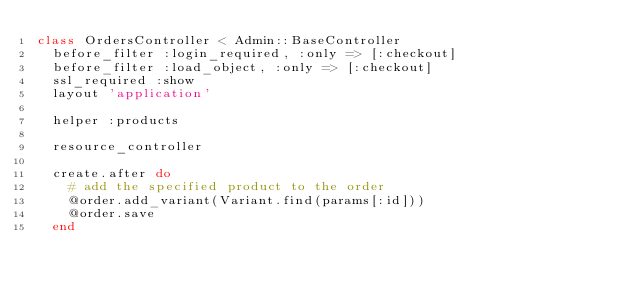<code> <loc_0><loc_0><loc_500><loc_500><_Ruby_>class OrdersController < Admin::BaseController
  before_filter :login_required, :only => [:checkout]
  before_filter :load_object, :only => [:checkout]
  ssl_required :show
  layout 'application'
  
  helper :products
  
  resource_controller

  create.after do    
    # add the specified product to the order
    @order.add_variant(Variant.find(params[:id]))    
    @order.save
  end
</code> 